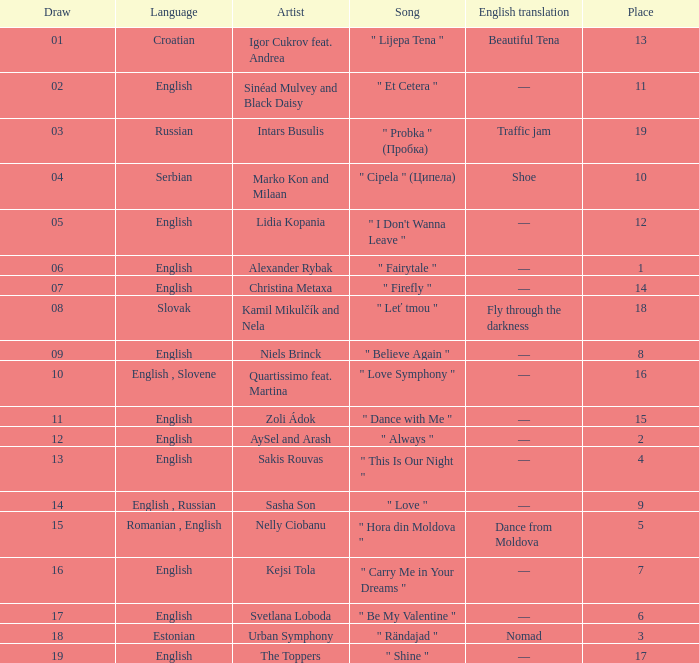In which place can a quartissimo and martina collaboration be found, given that the draw is less than 12? 16.0. 